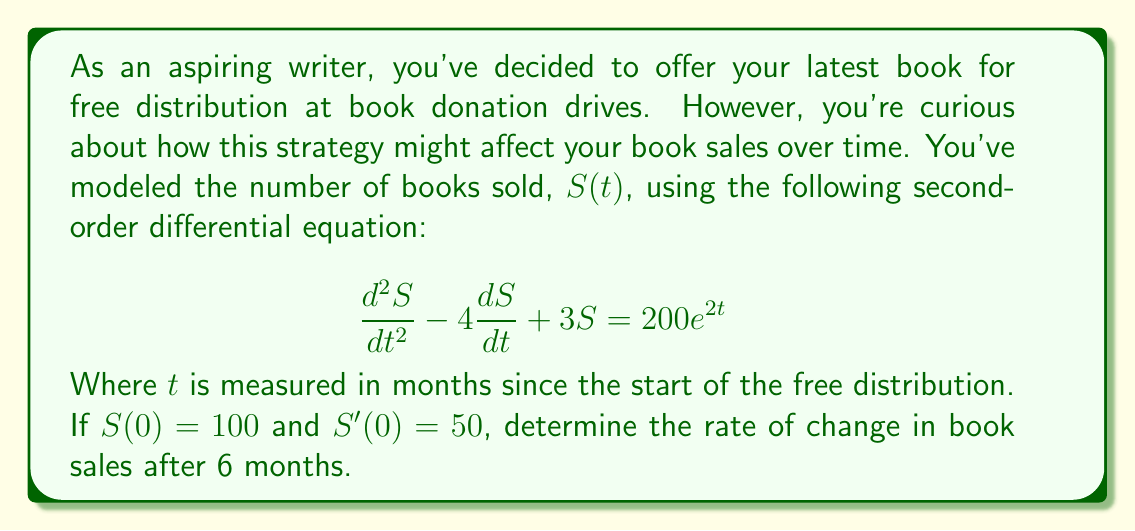What is the answer to this math problem? To solve this problem, we need to follow these steps:

1) The general solution to this differential equation is the sum of the complementary function and the particular integral.

2) The complementary function has the form:
   $$S_c(t) = Ae^{r_1t} + Be^{r_2t}$$
   where $r_1$ and $r_2$ are roots of the characteristic equation:
   $$r^2 - 4r + 3 = 0$$
   Solving this: $r_1 = 3$ and $r_2 = 1$

3) The particular integral has the form:
   $$S_p(t) = Ce^{2t}$$
   Substituting this into the original equation:
   $$4C - 8C + 3C = 200$$
   $$-C = 200$$
   $$C = -200$$

4) Therefore, the general solution is:
   $$S(t) = Ae^{3t} + Be^t - 200e^{2t}$$

5) Using the initial conditions:
   $S(0) = 100$: $A + B - 200 = 100$
   $S'(0) = 50$: $3A + B - 400 = 50$

6) Solving these simultaneous equations:
   $A = 150$ and $B = 150$

7) So the particular solution is:
   $$S(t) = 150e^{3t} + 150e^t - 200e^{2t}$$

8) To find the rate of change at 6 months, we differentiate this and evaluate at $t=6$:
   $$\frac{dS}{dt} = 450e^{3t} + 150e^t - 400e^{2t}$$
   $$\frac{dS}{dt}(6) = 450e^{18} + 150e^6 - 400e^{12}$$

9) Calculating this value gives us the rate of change at 6 months.
Answer: The rate of change in book sales after 6 months is approximately $3.4 \times 10^7$ books per month. 